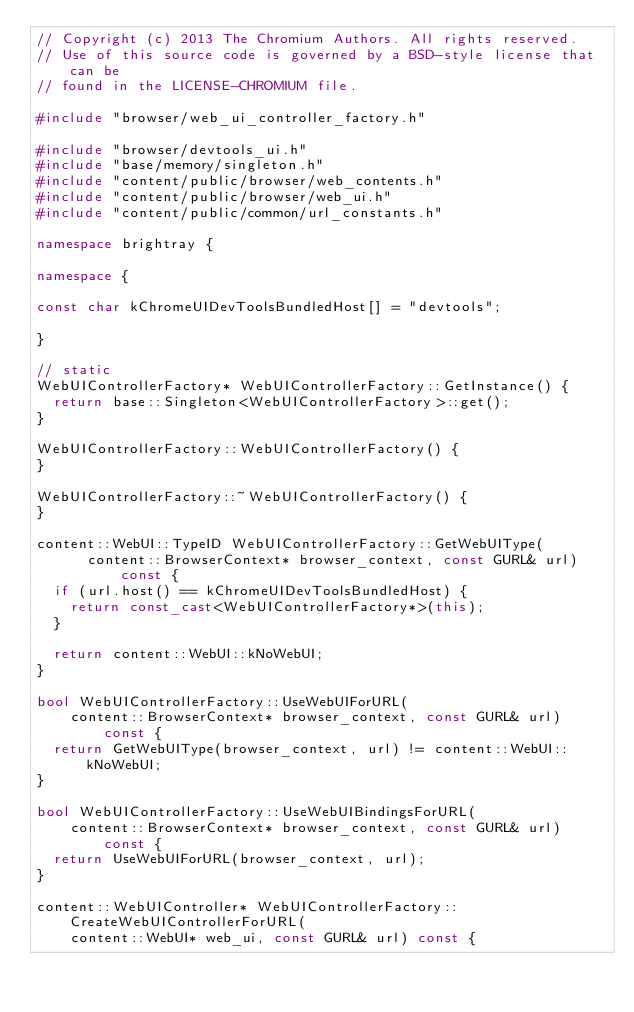Convert code to text. <code><loc_0><loc_0><loc_500><loc_500><_C++_>// Copyright (c) 2013 The Chromium Authors. All rights reserved.
// Use of this source code is governed by a BSD-style license that can be
// found in the LICENSE-CHROMIUM file.

#include "browser/web_ui_controller_factory.h"

#include "browser/devtools_ui.h"
#include "base/memory/singleton.h"
#include "content/public/browser/web_contents.h"
#include "content/public/browser/web_ui.h"
#include "content/public/common/url_constants.h"

namespace brightray {

namespace {

const char kChromeUIDevToolsBundledHost[] = "devtools";

}

// static
WebUIControllerFactory* WebUIControllerFactory::GetInstance() {
  return base::Singleton<WebUIControllerFactory>::get();
}

WebUIControllerFactory::WebUIControllerFactory() {
}

WebUIControllerFactory::~WebUIControllerFactory() {
}

content::WebUI::TypeID WebUIControllerFactory::GetWebUIType(
      content::BrowserContext* browser_context, const GURL& url) const {
  if (url.host() == kChromeUIDevToolsBundledHost) {
    return const_cast<WebUIControllerFactory*>(this);
  }

  return content::WebUI::kNoWebUI;
}

bool WebUIControllerFactory::UseWebUIForURL(
    content::BrowserContext* browser_context, const GURL& url) const {
  return GetWebUIType(browser_context, url) != content::WebUI::kNoWebUI;
}

bool WebUIControllerFactory::UseWebUIBindingsForURL(
    content::BrowserContext* browser_context, const GURL& url) const {
  return UseWebUIForURL(browser_context, url);
}

content::WebUIController* WebUIControllerFactory::CreateWebUIControllerForURL(
    content::WebUI* web_ui, const GURL& url) const {</code> 